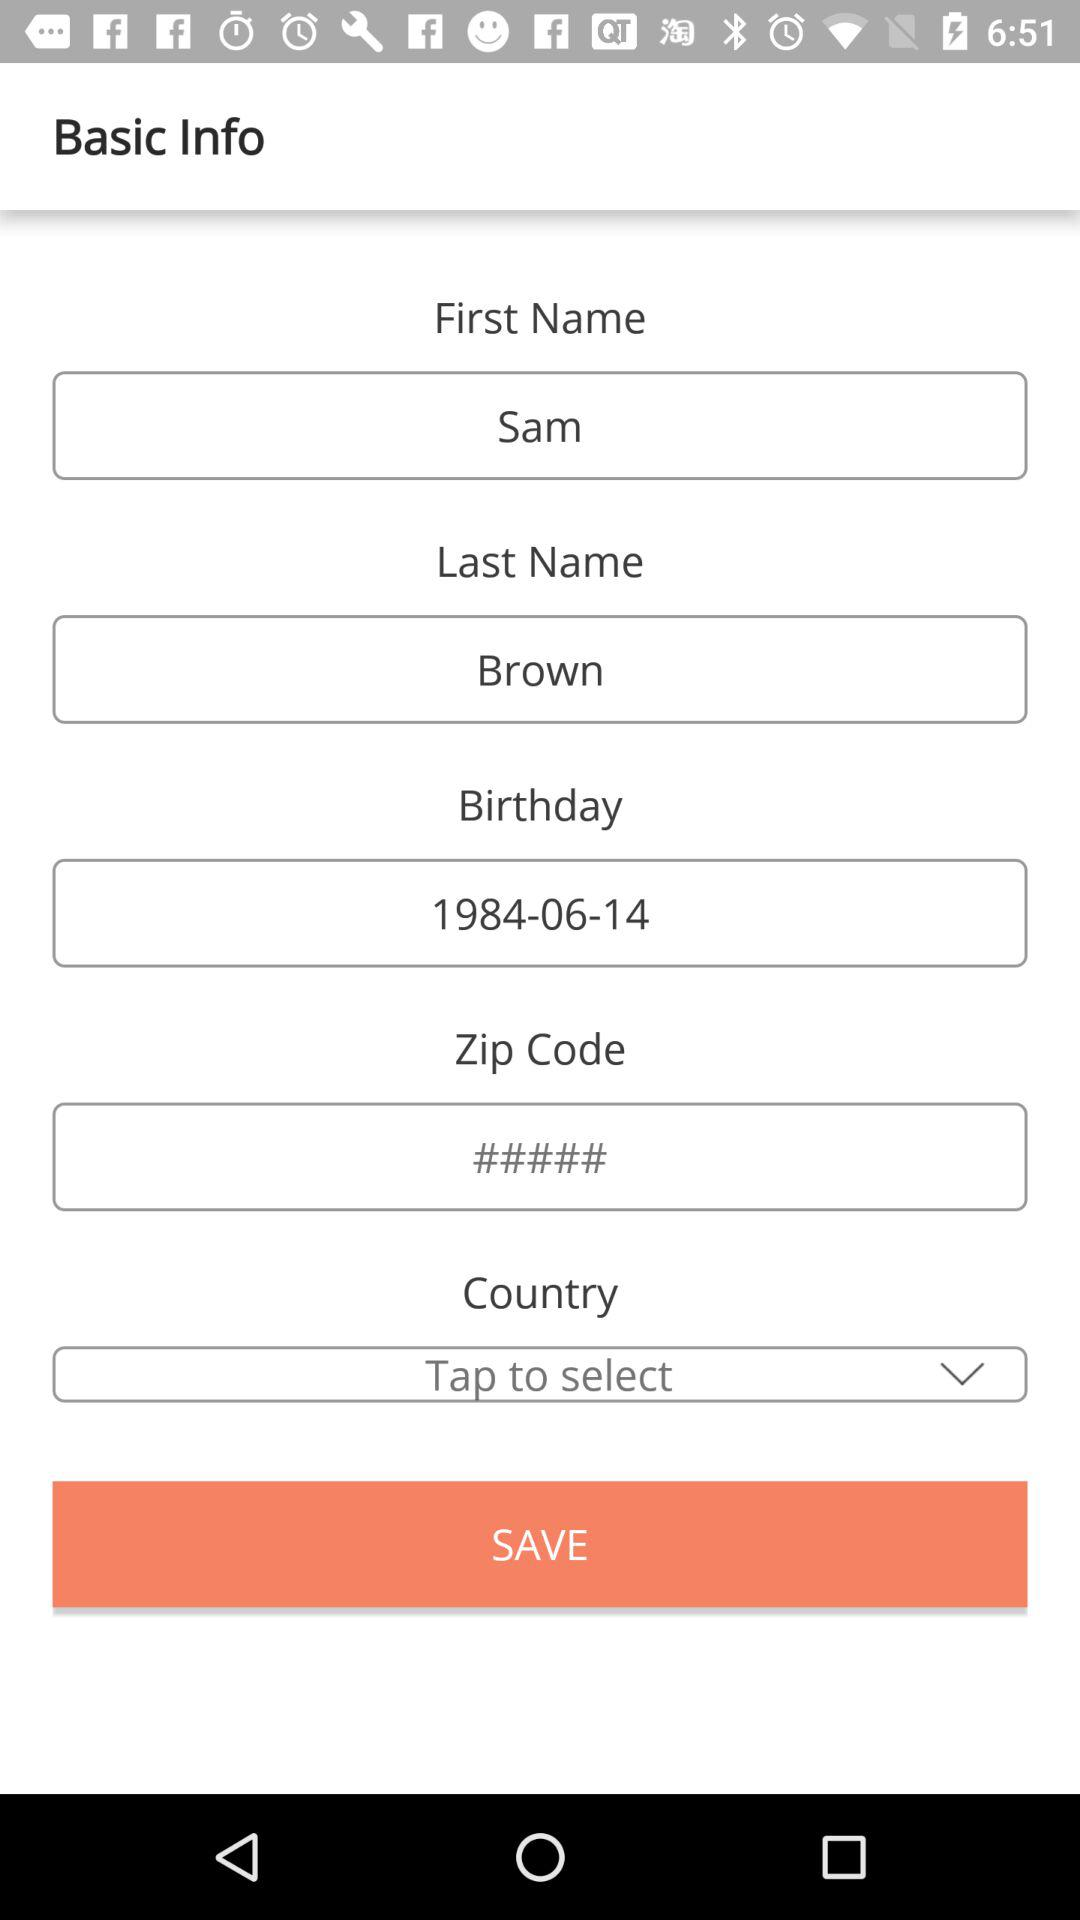What is the selected country?
When the provided information is insufficient, respond with <no answer>. <no answer> 